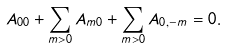<formula> <loc_0><loc_0><loc_500><loc_500>A _ { 0 0 } + \sum _ { m > 0 } A _ { m 0 } + \sum _ { m > 0 } A _ { 0 , - m } = 0 .</formula> 